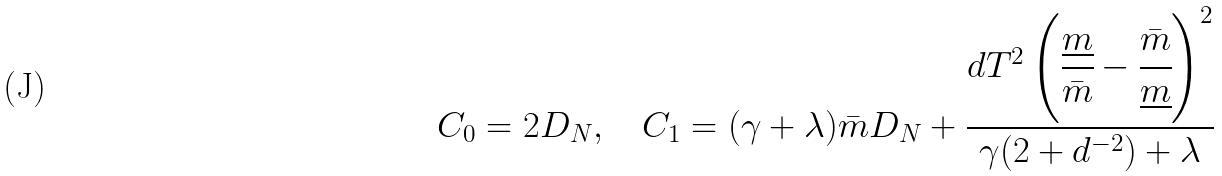<formula> <loc_0><loc_0><loc_500><loc_500>C _ { 0 } = 2 D _ { N } , \quad C _ { 1 } = ( \gamma + \lambda ) { \bar { m } } D _ { N } + \cfrac { d T ^ { 2 } \left ( \cfrac { \underline { m } } { \bar { m } } - \cfrac { \bar { m } } { \underline { m } } \right ) ^ { 2 } } { \gamma ( 2 + d ^ { - 2 } ) + \lambda }</formula> 